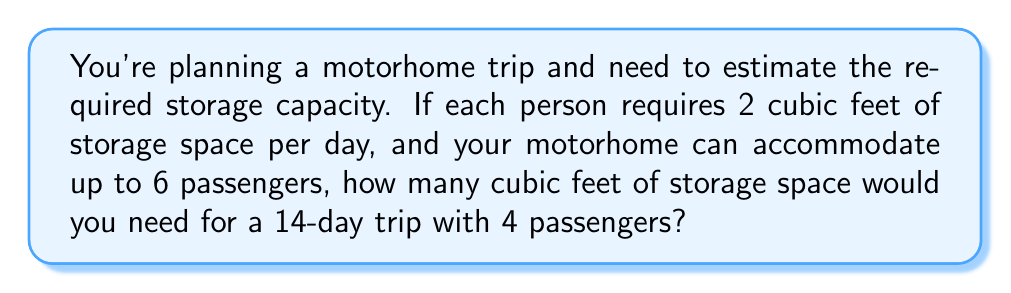Can you answer this question? To solve this problem, we'll follow these steps:

1. Determine the storage space required per person per day:
   $$ \text{Space per person per day} = 2 \text{ cubic feet} $$

2. Calculate the number of days for the trip:
   $$ \text{Number of days} = 14 $$

3. Determine the number of passengers:
   $$ \text{Number of passengers} = 4 $$

4. Calculate the total storage space required:
   $$ \begin{align*}
   \text{Total space} &= \text{Space per person per day} \times \text{Number of days} \times \text{Number of passengers} \\
   &= 2 \times 14 \times 4 \\
   &= 112 \text{ cubic feet}
   \end{align*} $$

Therefore, for a 14-day trip with 4 passengers, you would need 112 cubic feet of storage space in your motorhome.
Answer: $112 \text{ cubic feet}$ 